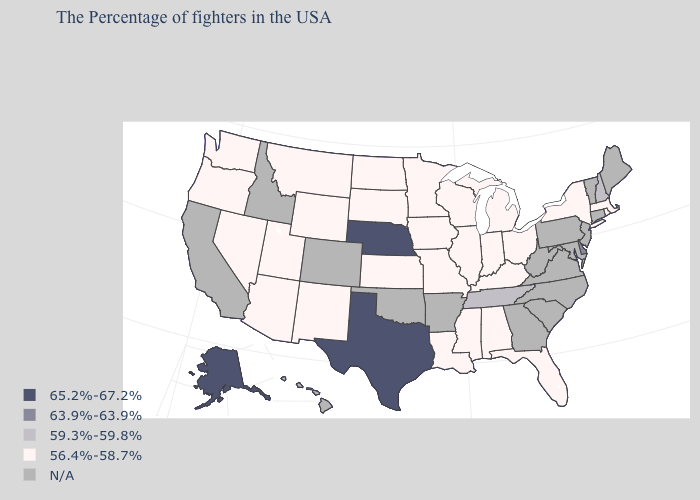Does Illinois have the lowest value in the USA?
Keep it brief. Yes. Which states have the highest value in the USA?
Quick response, please. Nebraska, Texas, Alaska. Name the states that have a value in the range 56.4%-58.7%?
Be succinct. Massachusetts, Rhode Island, New York, Ohio, Florida, Michigan, Kentucky, Indiana, Alabama, Wisconsin, Illinois, Mississippi, Louisiana, Missouri, Minnesota, Iowa, Kansas, South Dakota, North Dakota, Wyoming, New Mexico, Utah, Montana, Arizona, Nevada, Washington, Oregon. What is the value of Alaska?
Answer briefly. 65.2%-67.2%. What is the lowest value in states that border Minnesota?
Keep it brief. 56.4%-58.7%. What is the highest value in the South ?
Give a very brief answer. 65.2%-67.2%. Among the states that border New Mexico , which have the lowest value?
Write a very short answer. Utah, Arizona. What is the value of Iowa?
Keep it brief. 56.4%-58.7%. What is the value of Maryland?
Answer briefly. N/A. Which states have the lowest value in the Northeast?
Give a very brief answer. Massachusetts, Rhode Island, New York. Which states have the lowest value in the West?
Quick response, please. Wyoming, New Mexico, Utah, Montana, Arizona, Nevada, Washington, Oregon. Name the states that have a value in the range 59.3%-59.8%?
Be succinct. New Hampshire, Tennessee. What is the highest value in the West ?
Concise answer only. 65.2%-67.2%. What is the lowest value in the USA?
Answer briefly. 56.4%-58.7%. What is the highest value in the South ?
Short answer required. 65.2%-67.2%. 